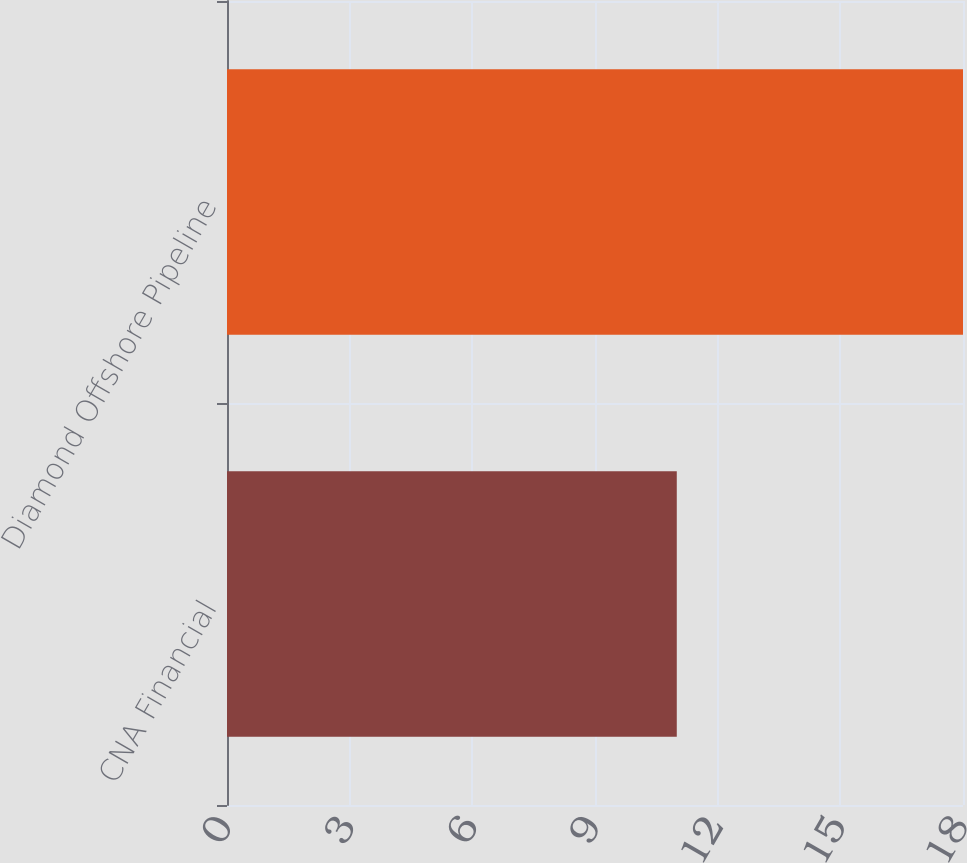Convert chart to OTSL. <chart><loc_0><loc_0><loc_500><loc_500><bar_chart><fcel>CNA Financial<fcel>Diamond Offshore Pipeline<nl><fcel>11<fcel>18<nl></chart> 